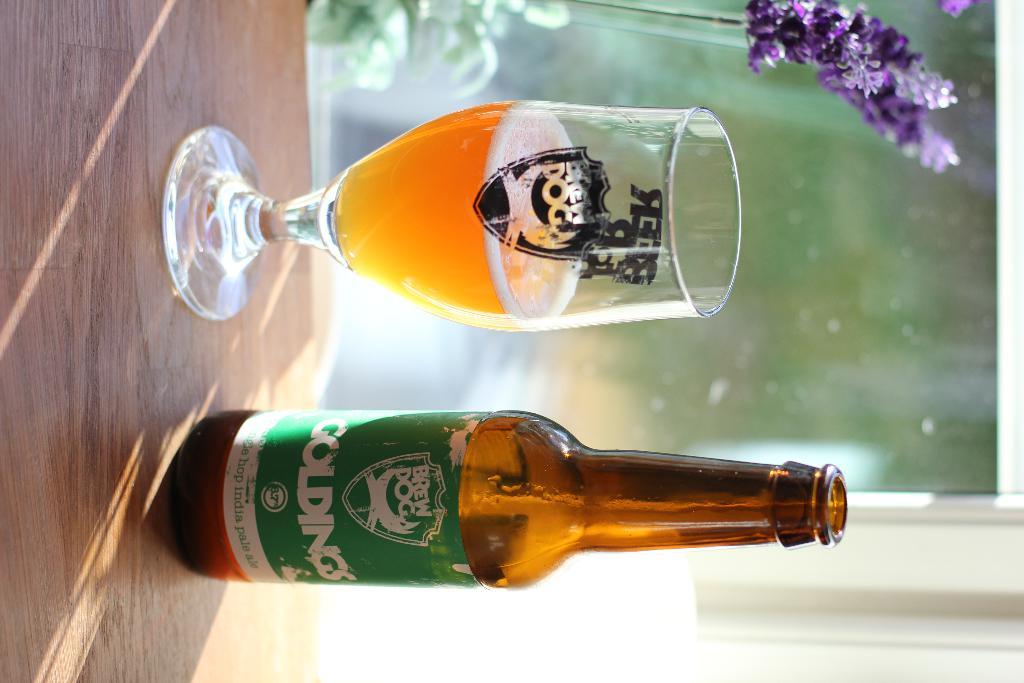What beverage is i nthe glass?
Keep it short and to the point. Beer. 